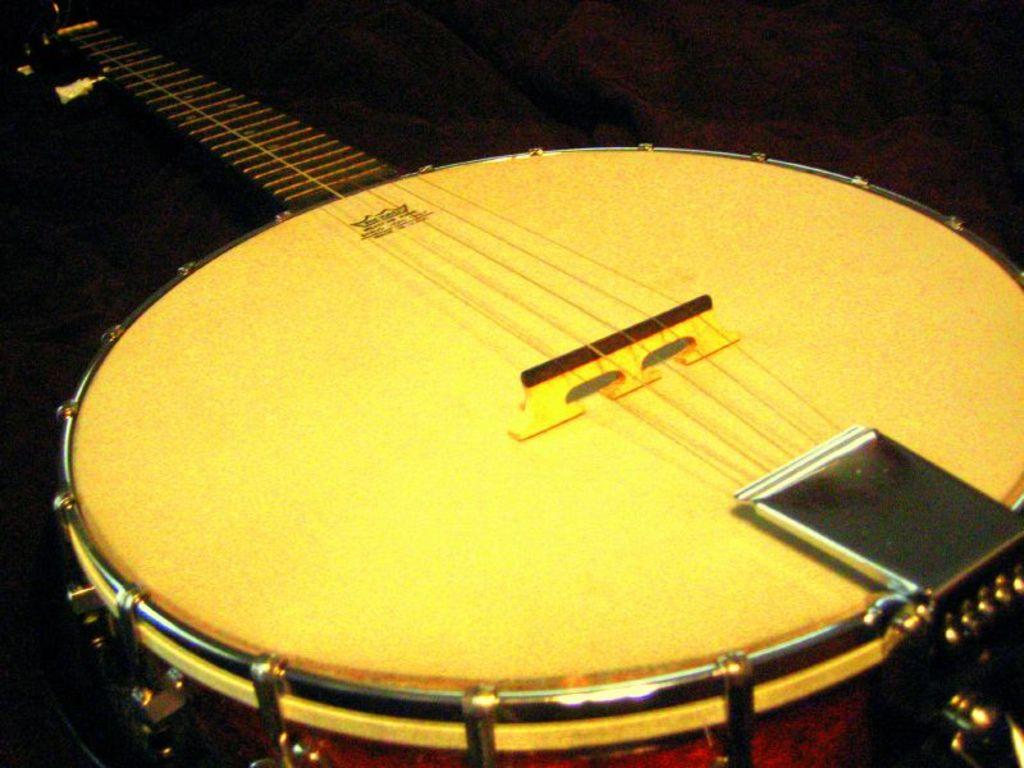What object in the image is associated with creating music? There is a musical instrument in the image. What type of engine can be seen powering the musical instrument in the image? There is no engine present in the image, as musical instruments do not have engines. How many snails are visible interacting with the musical instrument in the image? There are no snails present in the image, and therefore no such interaction can be observed. 